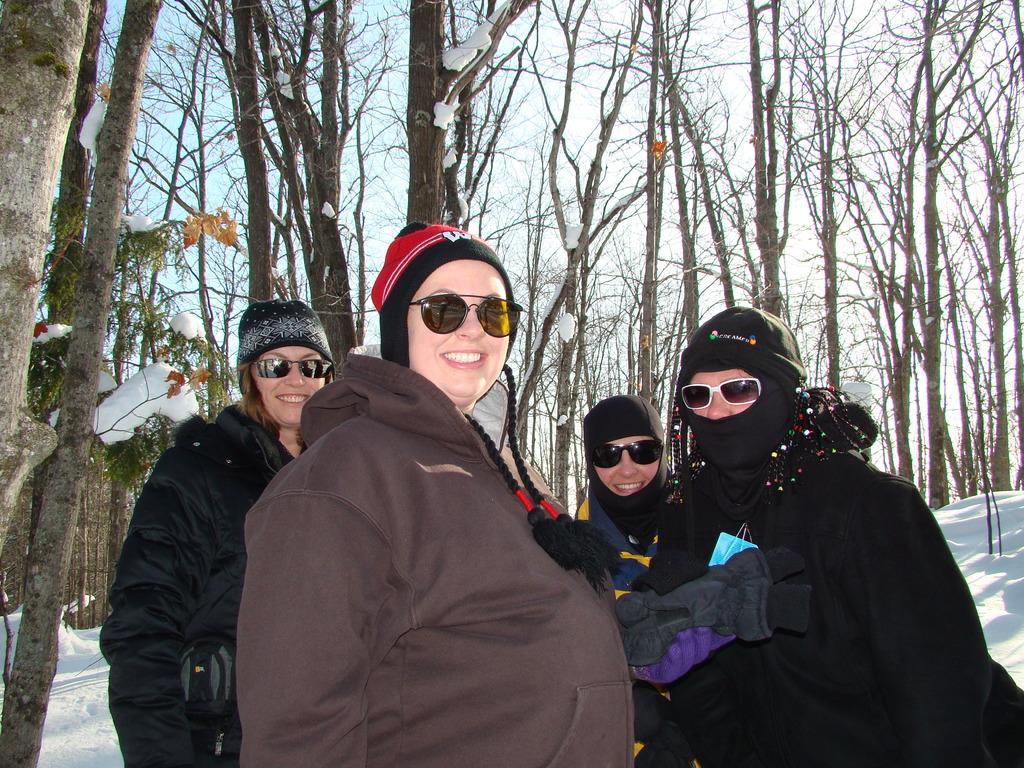Could you give a brief overview of what you see in this image? In the foreground of the picture I can see four women and there is a smile on their faces. They are wearing the jacket and goggles. In the background, I can see the trees and snow. 